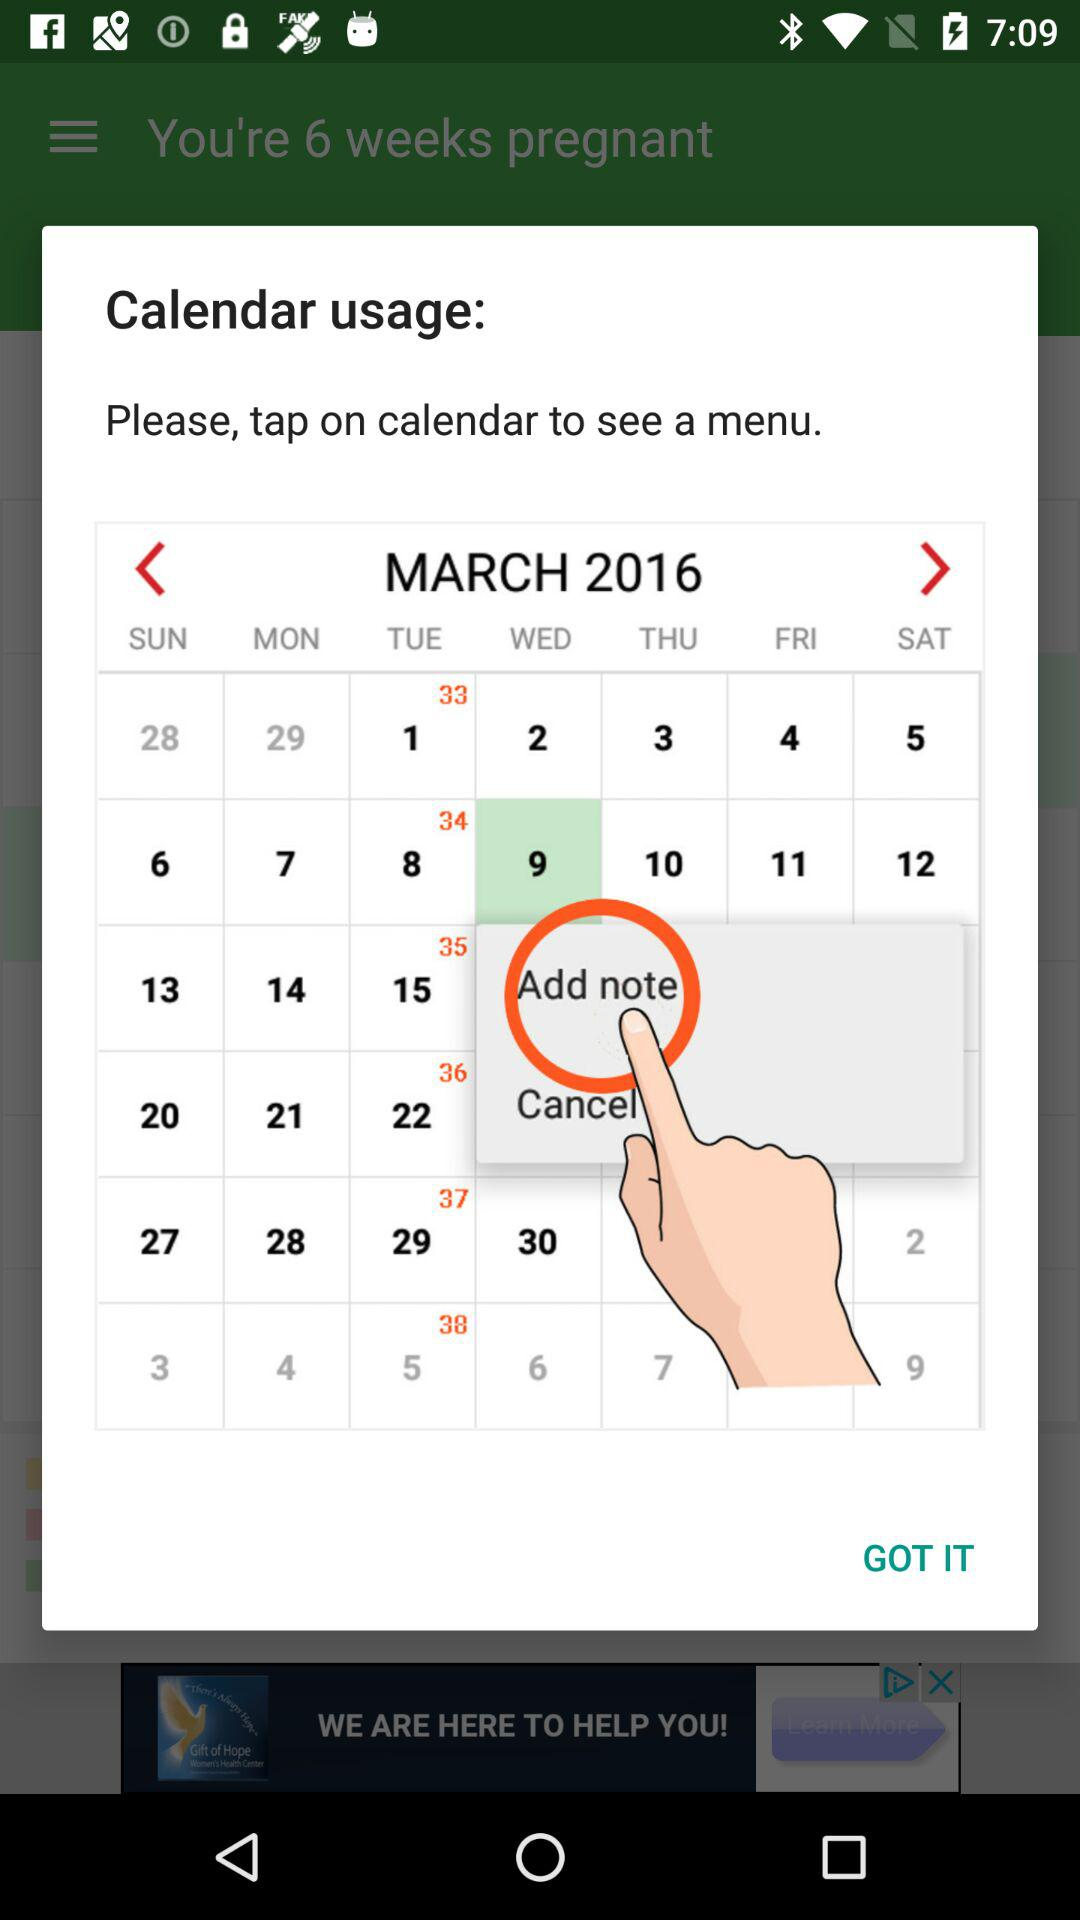What day falls on March 09, 2016? The day is Wednesday. 